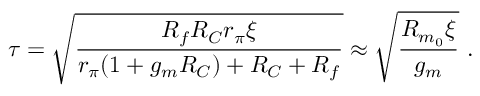<formula> <loc_0><loc_0><loc_500><loc_500>\tau = \sqrt { \frac { R _ { f } R _ { C } r _ { \pi } \xi } { r _ { \pi } ( 1 + g _ { m } R _ { C } ) + R _ { C } + R _ { f } } } \approx \sqrt { \frac { R _ { m _ { 0 } } \xi } { g _ { m } } } .</formula> 